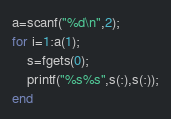<code> <loc_0><loc_0><loc_500><loc_500><_Octave_>a=scanf("%d\n",2);
for i=1:a(1);
	s=fgets(0);
    printf("%s%s",s(:),s(:));
end</code> 